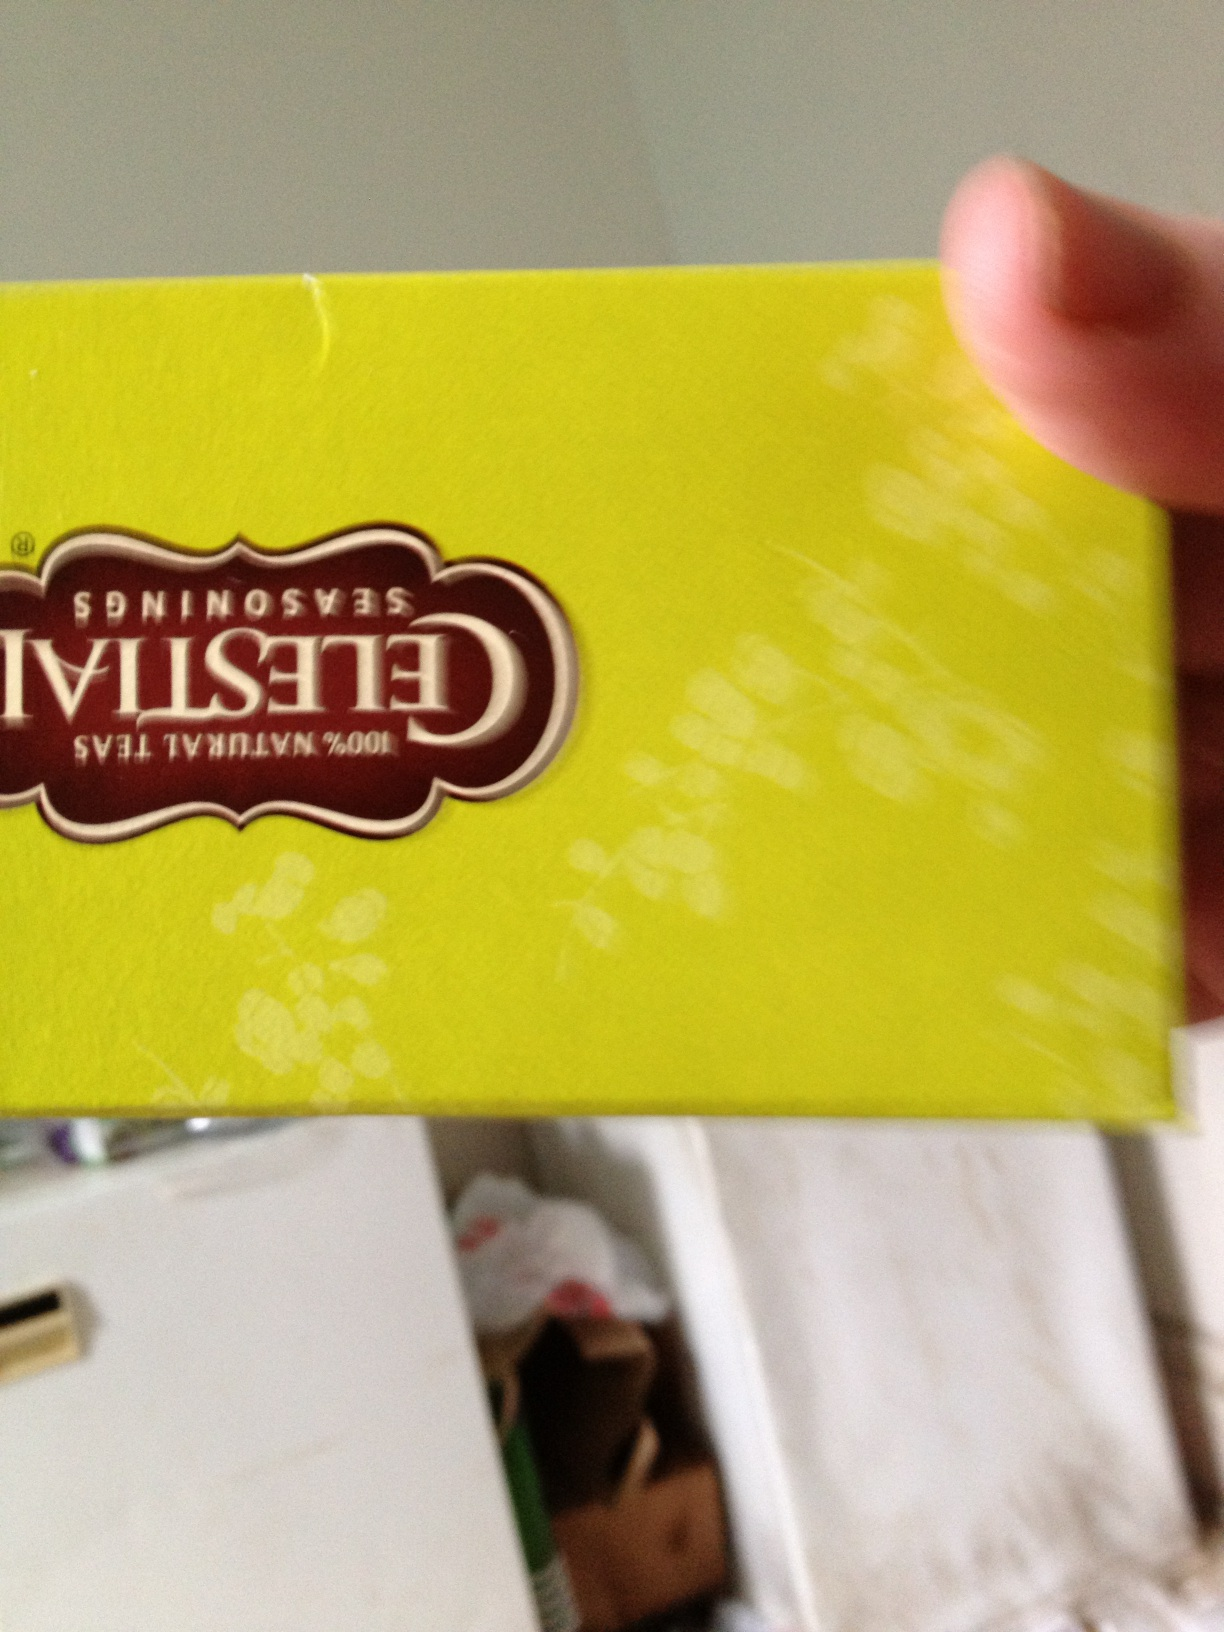What kind of tea is this? This is a box of Celestial Seasonings tea, a brand known for its variety of herbal and specialty teas. The vibrant green color of the packaging suggests that this particular blend might be one of their refreshing and light flavors, like their popular Green Tea or a citrus herbal blend. 